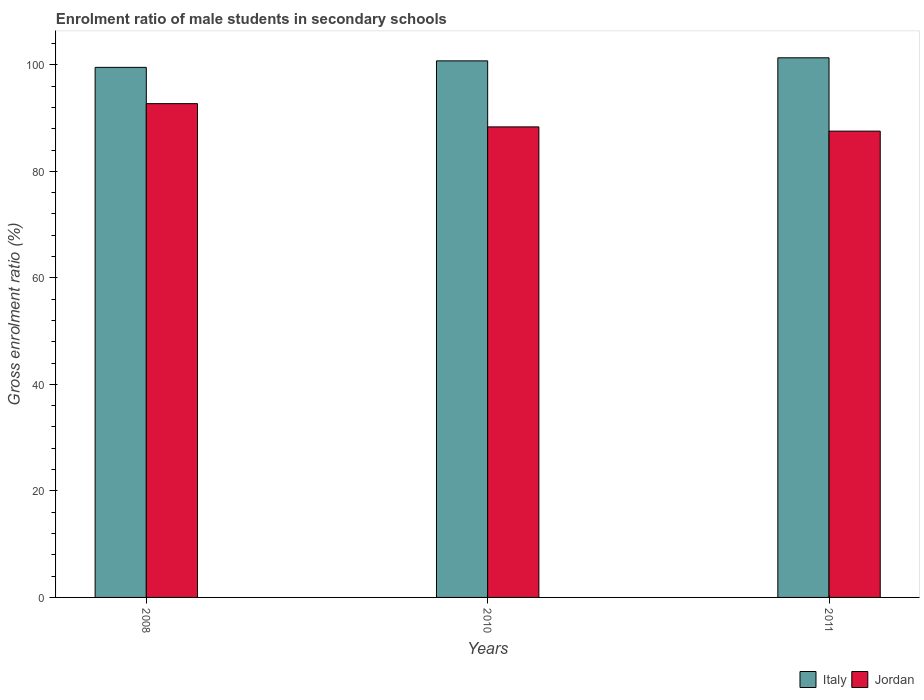How many groups of bars are there?
Offer a terse response. 3. Are the number of bars per tick equal to the number of legend labels?
Provide a short and direct response. Yes. What is the enrolment ratio of male students in secondary schools in Jordan in 2010?
Give a very brief answer. 88.34. Across all years, what is the maximum enrolment ratio of male students in secondary schools in Italy?
Your answer should be compact. 101.32. Across all years, what is the minimum enrolment ratio of male students in secondary schools in Italy?
Your answer should be very brief. 99.52. In which year was the enrolment ratio of male students in secondary schools in Italy maximum?
Offer a terse response. 2011. What is the total enrolment ratio of male students in secondary schools in Jordan in the graph?
Make the answer very short. 268.6. What is the difference between the enrolment ratio of male students in secondary schools in Jordan in 2008 and that in 2010?
Give a very brief answer. 4.37. What is the difference between the enrolment ratio of male students in secondary schools in Jordan in 2011 and the enrolment ratio of male students in secondary schools in Italy in 2008?
Provide a short and direct response. -11.97. What is the average enrolment ratio of male students in secondary schools in Jordan per year?
Ensure brevity in your answer.  89.53. In the year 2011, what is the difference between the enrolment ratio of male students in secondary schools in Italy and enrolment ratio of male students in secondary schools in Jordan?
Offer a very short reply. 13.77. In how many years, is the enrolment ratio of male students in secondary schools in Jordan greater than 32 %?
Ensure brevity in your answer.  3. What is the ratio of the enrolment ratio of male students in secondary schools in Jordan in 2008 to that in 2010?
Your answer should be very brief. 1.05. What is the difference between the highest and the second highest enrolment ratio of male students in secondary schools in Italy?
Give a very brief answer. 0.57. What is the difference between the highest and the lowest enrolment ratio of male students in secondary schools in Italy?
Give a very brief answer. 1.8. Is the sum of the enrolment ratio of male students in secondary schools in Jordan in 2008 and 2010 greater than the maximum enrolment ratio of male students in secondary schools in Italy across all years?
Your answer should be compact. Yes. What does the 2nd bar from the left in 2008 represents?
Give a very brief answer. Jordan. What does the 2nd bar from the right in 2010 represents?
Make the answer very short. Italy. How many bars are there?
Provide a succinct answer. 6. Are all the bars in the graph horizontal?
Your answer should be compact. No. How many years are there in the graph?
Offer a terse response. 3. How are the legend labels stacked?
Make the answer very short. Horizontal. What is the title of the graph?
Keep it short and to the point. Enrolment ratio of male students in secondary schools. Does "Lower middle income" appear as one of the legend labels in the graph?
Provide a short and direct response. No. What is the label or title of the Y-axis?
Give a very brief answer. Gross enrolment ratio (%). What is the Gross enrolment ratio (%) of Italy in 2008?
Ensure brevity in your answer.  99.52. What is the Gross enrolment ratio (%) in Jordan in 2008?
Offer a very short reply. 92.71. What is the Gross enrolment ratio (%) in Italy in 2010?
Ensure brevity in your answer.  100.74. What is the Gross enrolment ratio (%) of Jordan in 2010?
Provide a succinct answer. 88.34. What is the Gross enrolment ratio (%) in Italy in 2011?
Offer a very short reply. 101.32. What is the Gross enrolment ratio (%) in Jordan in 2011?
Your answer should be very brief. 87.55. Across all years, what is the maximum Gross enrolment ratio (%) of Italy?
Your response must be concise. 101.32. Across all years, what is the maximum Gross enrolment ratio (%) in Jordan?
Provide a short and direct response. 92.71. Across all years, what is the minimum Gross enrolment ratio (%) in Italy?
Your answer should be very brief. 99.52. Across all years, what is the minimum Gross enrolment ratio (%) in Jordan?
Provide a succinct answer. 87.55. What is the total Gross enrolment ratio (%) of Italy in the graph?
Your answer should be very brief. 301.58. What is the total Gross enrolment ratio (%) of Jordan in the graph?
Your answer should be compact. 268.6. What is the difference between the Gross enrolment ratio (%) of Italy in 2008 and that in 2010?
Make the answer very short. -1.22. What is the difference between the Gross enrolment ratio (%) in Jordan in 2008 and that in 2010?
Your answer should be compact. 4.37. What is the difference between the Gross enrolment ratio (%) in Italy in 2008 and that in 2011?
Provide a short and direct response. -1.8. What is the difference between the Gross enrolment ratio (%) of Jordan in 2008 and that in 2011?
Keep it short and to the point. 5.16. What is the difference between the Gross enrolment ratio (%) in Italy in 2010 and that in 2011?
Provide a short and direct response. -0.57. What is the difference between the Gross enrolment ratio (%) of Jordan in 2010 and that in 2011?
Make the answer very short. 0.8. What is the difference between the Gross enrolment ratio (%) in Italy in 2008 and the Gross enrolment ratio (%) in Jordan in 2010?
Make the answer very short. 11.18. What is the difference between the Gross enrolment ratio (%) of Italy in 2008 and the Gross enrolment ratio (%) of Jordan in 2011?
Make the answer very short. 11.97. What is the difference between the Gross enrolment ratio (%) in Italy in 2010 and the Gross enrolment ratio (%) in Jordan in 2011?
Offer a very short reply. 13.19. What is the average Gross enrolment ratio (%) of Italy per year?
Ensure brevity in your answer.  100.53. What is the average Gross enrolment ratio (%) of Jordan per year?
Offer a terse response. 89.53. In the year 2008, what is the difference between the Gross enrolment ratio (%) of Italy and Gross enrolment ratio (%) of Jordan?
Your answer should be very brief. 6.81. In the year 2010, what is the difference between the Gross enrolment ratio (%) of Italy and Gross enrolment ratio (%) of Jordan?
Make the answer very short. 12.4. In the year 2011, what is the difference between the Gross enrolment ratio (%) of Italy and Gross enrolment ratio (%) of Jordan?
Provide a short and direct response. 13.77. What is the ratio of the Gross enrolment ratio (%) of Italy in 2008 to that in 2010?
Your answer should be compact. 0.99. What is the ratio of the Gross enrolment ratio (%) of Jordan in 2008 to that in 2010?
Provide a short and direct response. 1.05. What is the ratio of the Gross enrolment ratio (%) in Italy in 2008 to that in 2011?
Offer a very short reply. 0.98. What is the ratio of the Gross enrolment ratio (%) of Jordan in 2008 to that in 2011?
Keep it short and to the point. 1.06. What is the ratio of the Gross enrolment ratio (%) of Jordan in 2010 to that in 2011?
Your response must be concise. 1.01. What is the difference between the highest and the second highest Gross enrolment ratio (%) of Italy?
Ensure brevity in your answer.  0.57. What is the difference between the highest and the second highest Gross enrolment ratio (%) of Jordan?
Provide a short and direct response. 4.37. What is the difference between the highest and the lowest Gross enrolment ratio (%) in Italy?
Make the answer very short. 1.8. What is the difference between the highest and the lowest Gross enrolment ratio (%) in Jordan?
Keep it short and to the point. 5.16. 